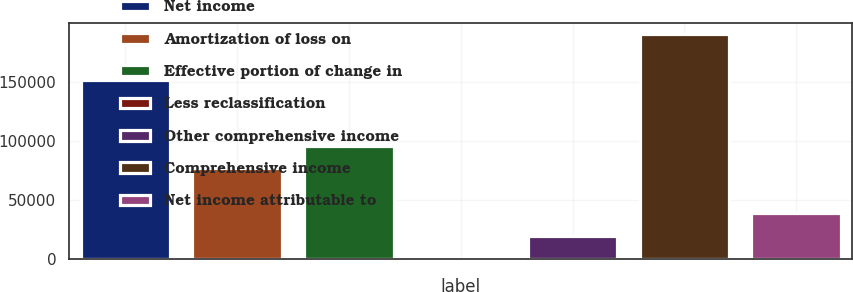Convert chart. <chart><loc_0><loc_0><loc_500><loc_500><bar_chart><fcel>Net income<fcel>Amortization of loss on<fcel>Effective portion of change in<fcel>Less reclassification<fcel>Other comprehensive income<fcel>Comprehensive income<fcel>Net income attributable to<nl><fcel>151285<fcel>76701<fcel>95868<fcel>33<fcel>19200<fcel>190115<fcel>38367<nl></chart> 